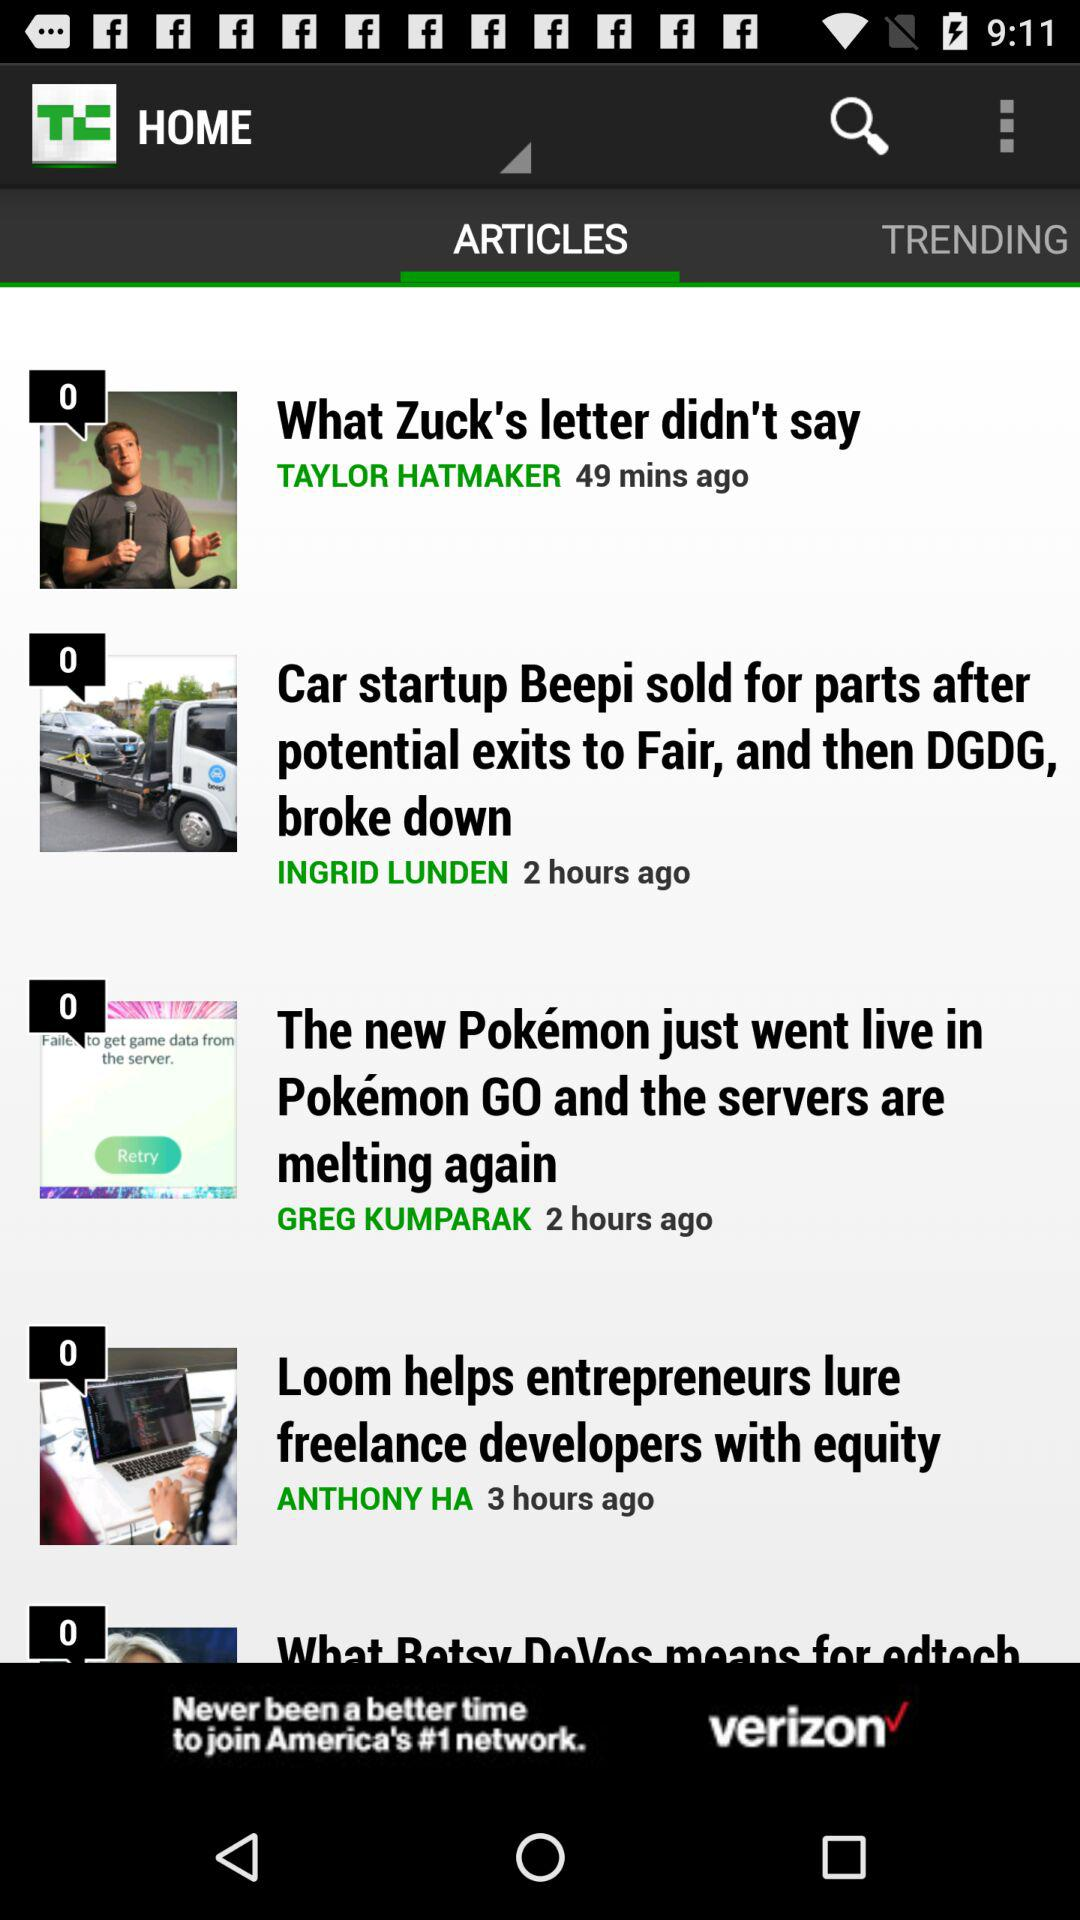How many people like the post "What Zuck's letter didn't say"?
When the provided information is insufficient, respond with <no answer>. <no answer> 